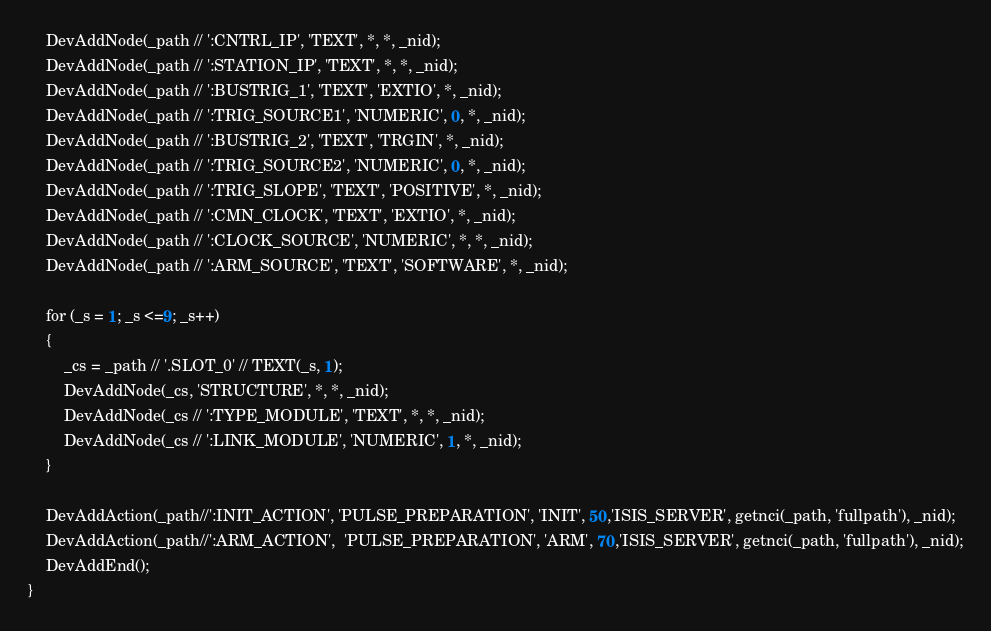<code> <loc_0><loc_0><loc_500><loc_500><_SML_>    DevAddNode(_path // ':CNTRL_IP', 'TEXT', *, *, _nid);
    DevAddNode(_path // ':STATION_IP', 'TEXT', *, *, _nid);
    DevAddNode(_path // ':BUSTRIG_1', 'TEXT', 'EXTIO', *, _nid);
    DevAddNode(_path // ':TRIG_SOURCE1', 'NUMERIC', 0, *, _nid);
    DevAddNode(_path // ':BUSTRIG_2', 'TEXT', 'TRGIN', *, _nid);
    DevAddNode(_path // ':TRIG_SOURCE2', 'NUMERIC', 0, *, _nid);
    DevAddNode(_path // ':TRIG_SLOPE', 'TEXT', 'POSITIVE', *, _nid);
    DevAddNode(_path // ':CMN_CLOCK', 'TEXT', 'EXTIO', *, _nid);
    DevAddNode(_path // ':CLOCK_SOURCE', 'NUMERIC', *, *, _nid);
    DevAddNode(_path // ':ARM_SOURCE', 'TEXT', 'SOFTWARE', *, _nid);

    for (_s = 1; _s <=9; _s++)
    {
        _cs = _path // '.SLOT_0' // TEXT(_s, 1);
		DevAddNode(_cs, 'STRUCTURE', *, *, _nid);
    	DevAddNode(_cs // ':TYPE_MODULE', 'TEXT', *, *, _nid);
		DevAddNode(_cs // ':LINK_MODULE', 'NUMERIC', 1, *, _nid);
	}

    DevAddAction(_path//':INIT_ACTION', 'PULSE_PREPARATION', 'INIT', 50,'ISIS_SERVER', getnci(_path, 'fullpath'), _nid);
    DevAddAction(_path//':ARM_ACTION',  'PULSE_PREPARATION', 'ARM', 70,'ISIS_SERVER', getnci(_path, 'fullpath'), _nid);
    DevAddEnd();
}
</code> 